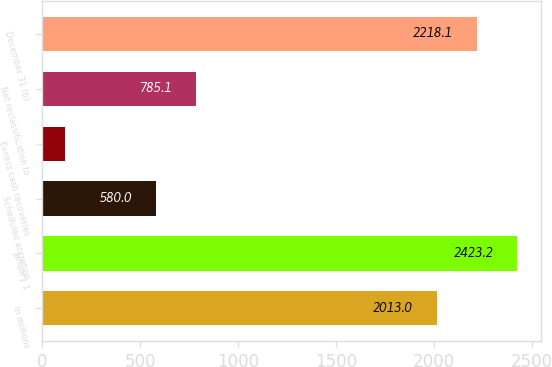<chart> <loc_0><loc_0><loc_500><loc_500><bar_chart><fcel>In millions<fcel>January 1<fcel>Scheduled accretion<fcel>Excess cash recoveries<fcel>Net reclassification to<fcel>December 31 (b)<nl><fcel>2013<fcel>2423.2<fcel>580<fcel>115<fcel>785.1<fcel>2218.1<nl></chart> 